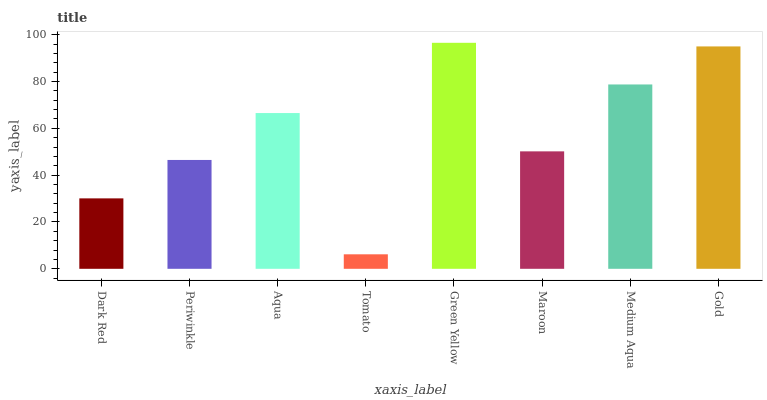Is Tomato the minimum?
Answer yes or no. Yes. Is Green Yellow the maximum?
Answer yes or no. Yes. Is Periwinkle the minimum?
Answer yes or no. No. Is Periwinkle the maximum?
Answer yes or no. No. Is Periwinkle greater than Dark Red?
Answer yes or no. Yes. Is Dark Red less than Periwinkle?
Answer yes or no. Yes. Is Dark Red greater than Periwinkle?
Answer yes or no. No. Is Periwinkle less than Dark Red?
Answer yes or no. No. Is Aqua the high median?
Answer yes or no. Yes. Is Maroon the low median?
Answer yes or no. Yes. Is Medium Aqua the high median?
Answer yes or no. No. Is Periwinkle the low median?
Answer yes or no. No. 